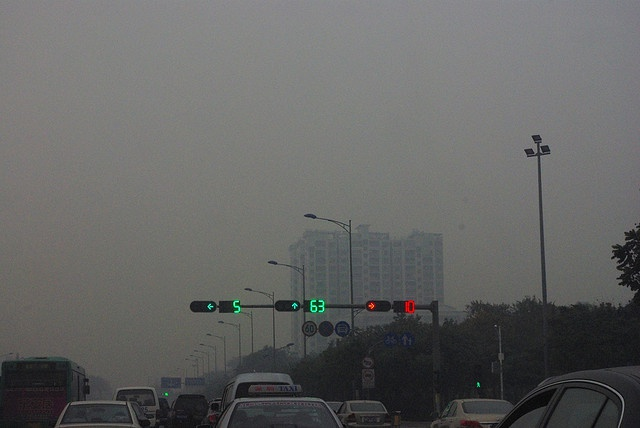Describe the objects in this image and their specific colors. I can see car in gray and black tones, bus in gray and black tones, car in gray, black, and purple tones, car in gray, black, and purple tones, and car in gray, black, and purple tones in this image. 